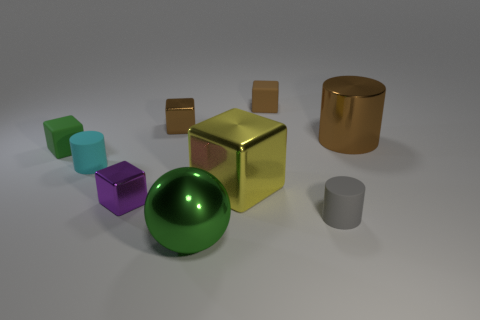What is the size of the rubber thing that is the same color as the ball?
Provide a succinct answer. Small. There is a object that is the same color as the large metal ball; what shape is it?
Your answer should be very brief. Cube. There is a small rubber block on the right side of the large green shiny ball; is it the same color as the large thing on the right side of the gray object?
Make the answer very short. Yes. Is there any other thing of the same color as the shiny sphere?
Your response must be concise. Yes. How many small matte objects are the same color as the big ball?
Offer a terse response. 1. How many red things are matte objects or rubber blocks?
Your response must be concise. 0. How big is the shiny cube that is behind the big thing that is right of the small brown matte thing on the left side of the large brown object?
Your response must be concise. Small. The green matte thing that is the same shape as the large yellow thing is what size?
Offer a terse response. Small. How many tiny objects are either brown things or gray cylinders?
Make the answer very short. 3. Is the material of the small block that is to the left of the cyan object the same as the small cylinder behind the gray cylinder?
Your answer should be compact. Yes. 